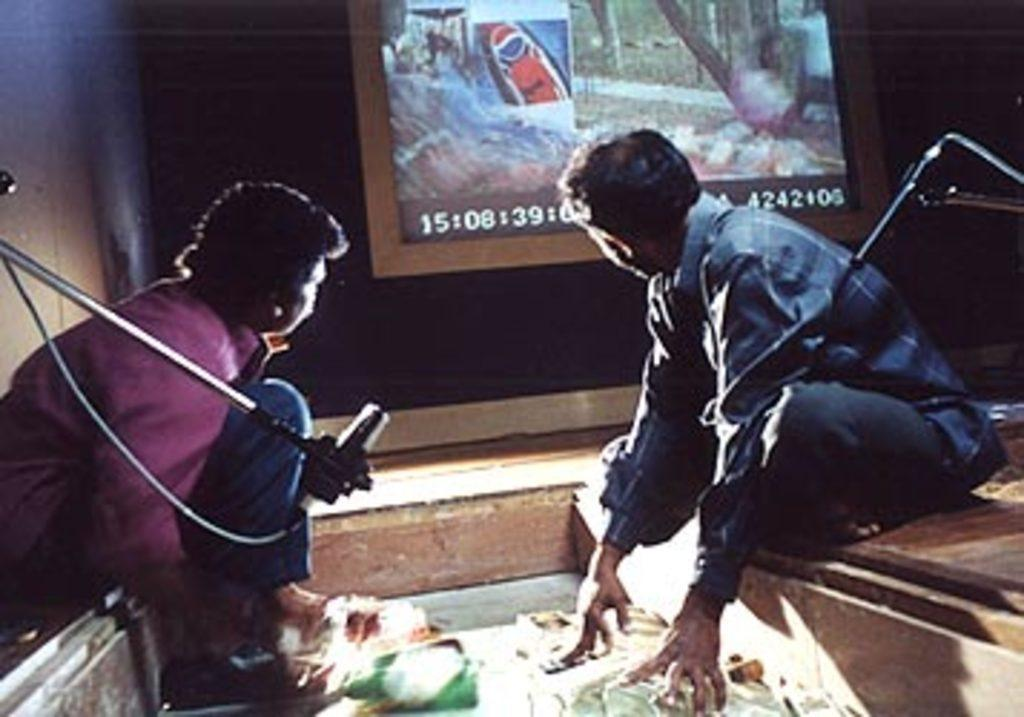What are the people in the image doing? The people in the image are sitting. What object is beside the people? There is a mic with a stand beside the people. What can be seen on the wall in the image? There is a banner on the wall in the image. What type of ball is being used by the people in the image? There is no ball present in the image; the people are sitting and there is a mic with a stand beside them. Can you tell me how many toothbrushes are visible in the image? There are no toothbrushes visible in the image. 